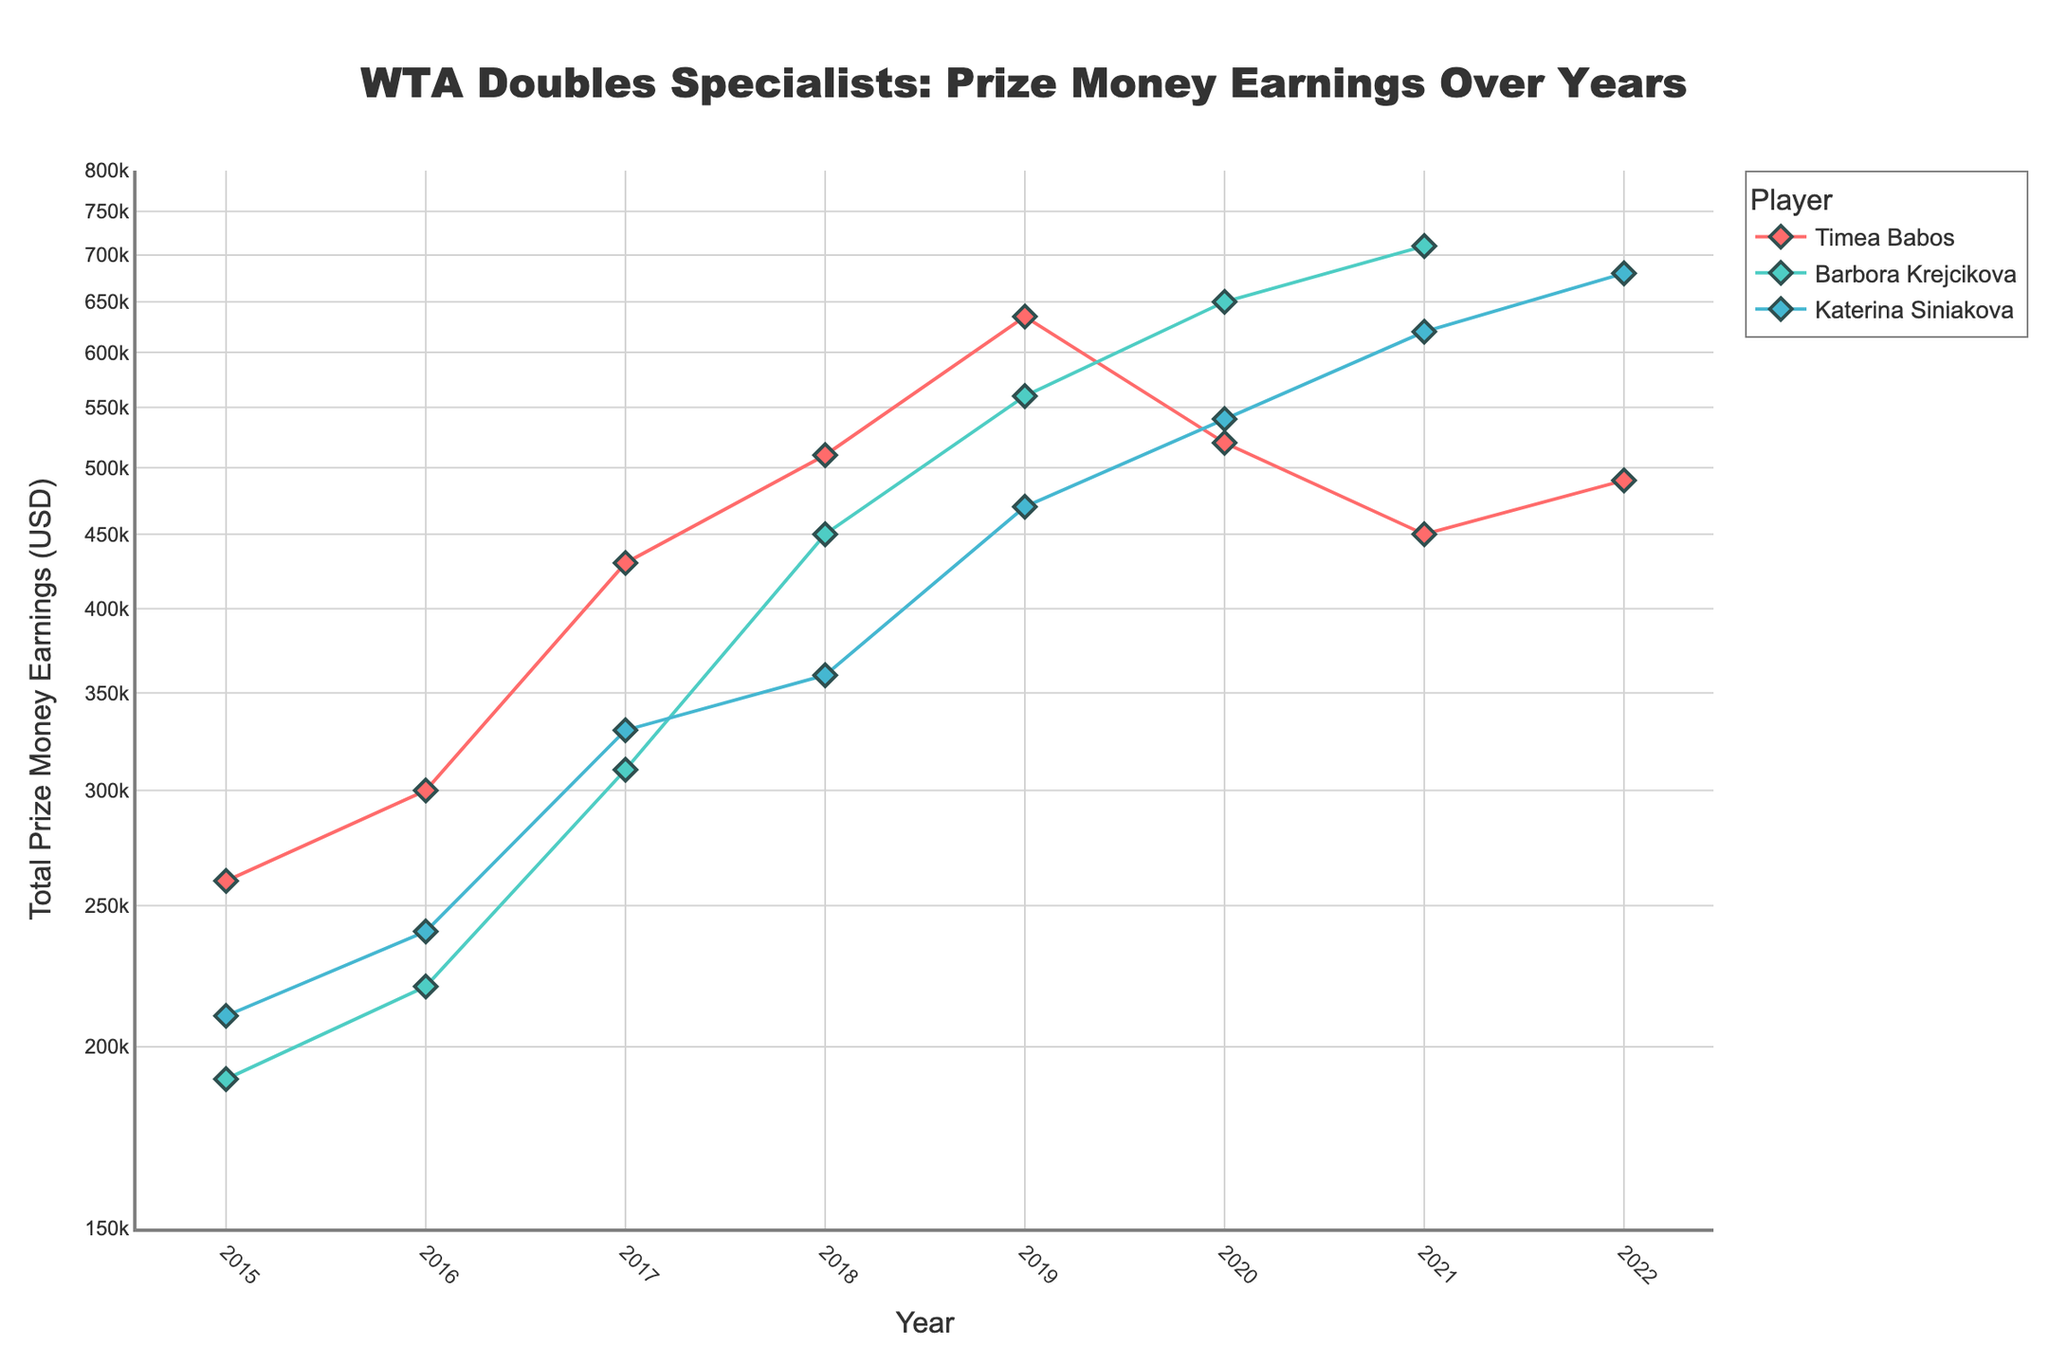What is the title of the plot? The title is usually shown at the top of a figure. In this scatter plot, it is prominently displayed in a larger font than the other text.
Answer: WTA Doubles Specialists: Prize Money Earnings Over Years Which player has the highest total prize money earnings in 2021? By looking along the year 2021 on the x-axis, we can compare the y-values for each player. The player with the highest y-value has the highest earnings.
Answer: Barbora Krejcikova What is the y-axis range for the prize money earnings? The y-axis range can be determined by looking at the minimum and maximum values labeled on the axis.
Answer: 150,000 to 800,000 USD Which player's earnings increased the most from 2015 to 2019? First, we find the earnings in 2015 and 2019 for each player. Then calculate the difference for each player and compare the differences.
Answer: Timea Babos Is there a player whose earnings never decreased year-on-year? By examining the trend line for each player, we look for a consistent upward trend without any drops from one year to the next.
Answer: Katerina Siniakova In which year did Timea Babos have the highest earnings? By tracing Timea Babos' data points and finding the peak y-value, we can determine the year associated with that peak.
Answer: 2019 What is the average prize money earnings for Katerina Siniakova over the years shown? Sum all earnings data points for Katerina Siniakova and divide by the number of years included in the data.
Answer: 431,250 USD How do the earnings of Timea Babos in 2020 compare to those in 2022? Find the y-values for Timea Babos for the years 2020 and 2022. Subtract 2020's earnings from 2022's to determine if there is an increase or decrease.
Answer: Decreased Which year shows the highest combined earnings for all three players? For each year, add the earnings of all three players and compare the sums. The year with the highest sum has the highest combined earnings.
Answer: 2021 What's the trend in total prize money earnings for Barbora Krejcikova from 2015 to 2021? Trace the data points for Barbora Krejcikova over these years. Note the general direction of the trend line, whether it’s upwards, downwards or fluctuating.
Answer: Increasing 